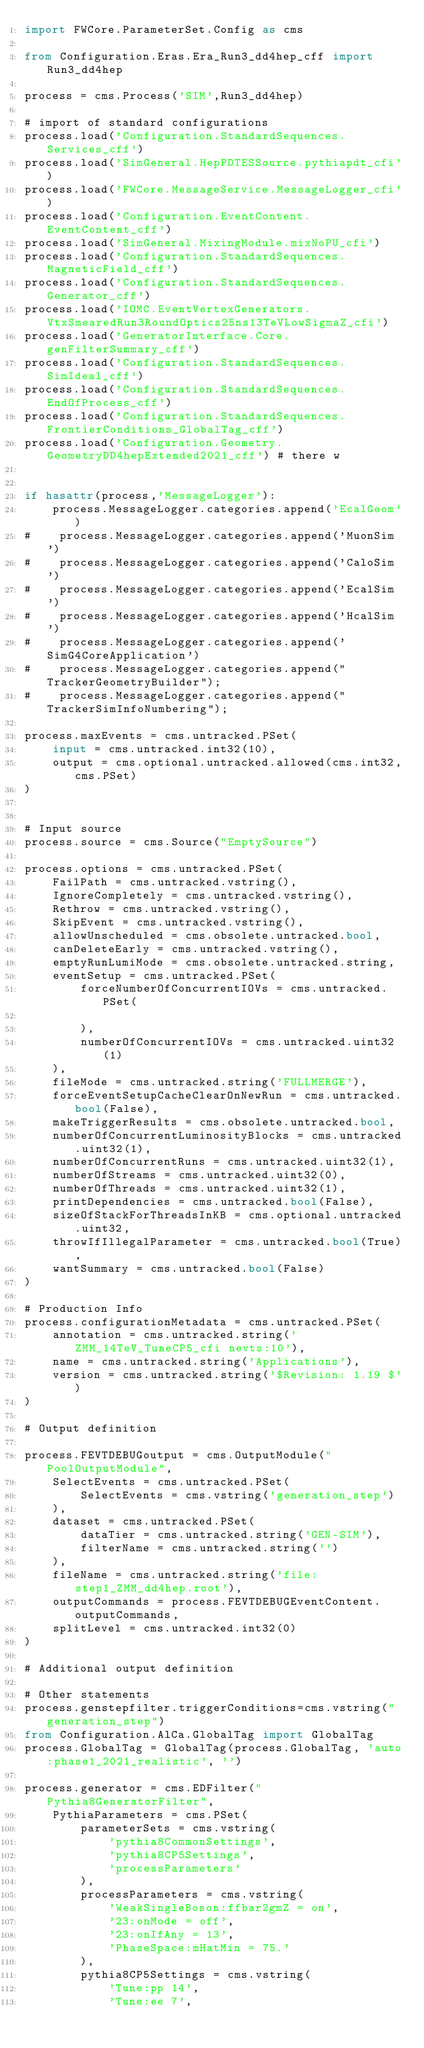Convert code to text. <code><loc_0><loc_0><loc_500><loc_500><_Python_>import FWCore.ParameterSet.Config as cms

from Configuration.Eras.Era_Run3_dd4hep_cff import Run3_dd4hep

process = cms.Process('SIM',Run3_dd4hep)

# import of standard configurations
process.load('Configuration.StandardSequences.Services_cff')
process.load('SimGeneral.HepPDTESSource.pythiapdt_cfi')
process.load('FWCore.MessageService.MessageLogger_cfi')
process.load('Configuration.EventContent.EventContent_cff')
process.load('SimGeneral.MixingModule.mixNoPU_cfi')
process.load('Configuration.StandardSequences.MagneticField_cff')
process.load('Configuration.StandardSequences.Generator_cff')
process.load('IOMC.EventVertexGenerators.VtxSmearedRun3RoundOptics25ns13TeVLowSigmaZ_cfi')
process.load('GeneratorInterface.Core.genFilterSummary_cff')
process.load('Configuration.StandardSequences.SimIdeal_cff')
process.load('Configuration.StandardSequences.EndOfProcess_cff')
process.load('Configuration.StandardSequences.FrontierConditions_GlobalTag_cff')
process.load('Configuration.Geometry.GeometryDD4hepExtended2021_cff') # there w


if hasattr(process,'MessageLogger'):
    process.MessageLogger.categories.append('EcalGeom')
#    process.MessageLogger.categories.append('MuonSim')
#    process.MessageLogger.categories.append('CaloSim')
#    process.MessageLogger.categories.append('EcalSim')
#    process.MessageLogger.categories.append('HcalSim')
#    process.MessageLogger.categories.append('SimG4CoreApplication')
#    process.MessageLogger.categories.append("TrackerGeometryBuilder");
#    process.MessageLogger.categories.append("TrackerSimInfoNumbering");

process.maxEvents = cms.untracked.PSet(
    input = cms.untracked.int32(10),
    output = cms.optional.untracked.allowed(cms.int32,cms.PSet)
)


# Input source
process.source = cms.Source("EmptySource")

process.options = cms.untracked.PSet(
    FailPath = cms.untracked.vstring(),
    IgnoreCompletely = cms.untracked.vstring(),
    Rethrow = cms.untracked.vstring(),
    SkipEvent = cms.untracked.vstring(),
    allowUnscheduled = cms.obsolete.untracked.bool,
    canDeleteEarly = cms.untracked.vstring(),
    emptyRunLumiMode = cms.obsolete.untracked.string,
    eventSetup = cms.untracked.PSet(
        forceNumberOfConcurrentIOVs = cms.untracked.PSet(

        ),
        numberOfConcurrentIOVs = cms.untracked.uint32(1)
    ),
    fileMode = cms.untracked.string('FULLMERGE'),
    forceEventSetupCacheClearOnNewRun = cms.untracked.bool(False),
    makeTriggerResults = cms.obsolete.untracked.bool,
    numberOfConcurrentLuminosityBlocks = cms.untracked.uint32(1),
    numberOfConcurrentRuns = cms.untracked.uint32(1),
    numberOfStreams = cms.untracked.uint32(0),
    numberOfThreads = cms.untracked.uint32(1),
    printDependencies = cms.untracked.bool(False),
    sizeOfStackForThreadsInKB = cms.optional.untracked.uint32,
    throwIfIllegalParameter = cms.untracked.bool(True),
    wantSummary = cms.untracked.bool(False)
)

# Production Info
process.configurationMetadata = cms.untracked.PSet(
    annotation = cms.untracked.string('ZMM_14TeV_TuneCP5_cfi nevts:10'),
    name = cms.untracked.string('Applications'),
    version = cms.untracked.string('$Revision: 1.19 $')
)

# Output definition

process.FEVTDEBUGoutput = cms.OutputModule("PoolOutputModule",
    SelectEvents = cms.untracked.PSet(
        SelectEvents = cms.vstring('generation_step')
    ),
    dataset = cms.untracked.PSet(
        dataTier = cms.untracked.string('GEN-SIM'),
        filterName = cms.untracked.string('')
    ),
    fileName = cms.untracked.string('file:step1_ZMM_dd4hep.root'),
    outputCommands = process.FEVTDEBUGEventContent.outputCommands,
    splitLevel = cms.untracked.int32(0)
)

# Additional output definition

# Other statements
process.genstepfilter.triggerConditions=cms.vstring("generation_step")
from Configuration.AlCa.GlobalTag import GlobalTag 
process.GlobalTag = GlobalTag(process.GlobalTag, 'auto:phase1_2021_realistic', '')

process.generator = cms.EDFilter("Pythia8GeneratorFilter",
    PythiaParameters = cms.PSet(
        parameterSets = cms.vstring(
            'pythia8CommonSettings', 
            'pythia8CP5Settings', 
            'processParameters'
        ),
        processParameters = cms.vstring(
            'WeakSingleBoson:ffbar2gmZ = on', 
            '23:onMode = off', 
            '23:onIfAny = 13', 
            'PhaseSpace:mHatMin = 75.'
        ),
        pythia8CP5Settings = cms.vstring(
            'Tune:pp 14', 
            'Tune:ee 7', </code> 